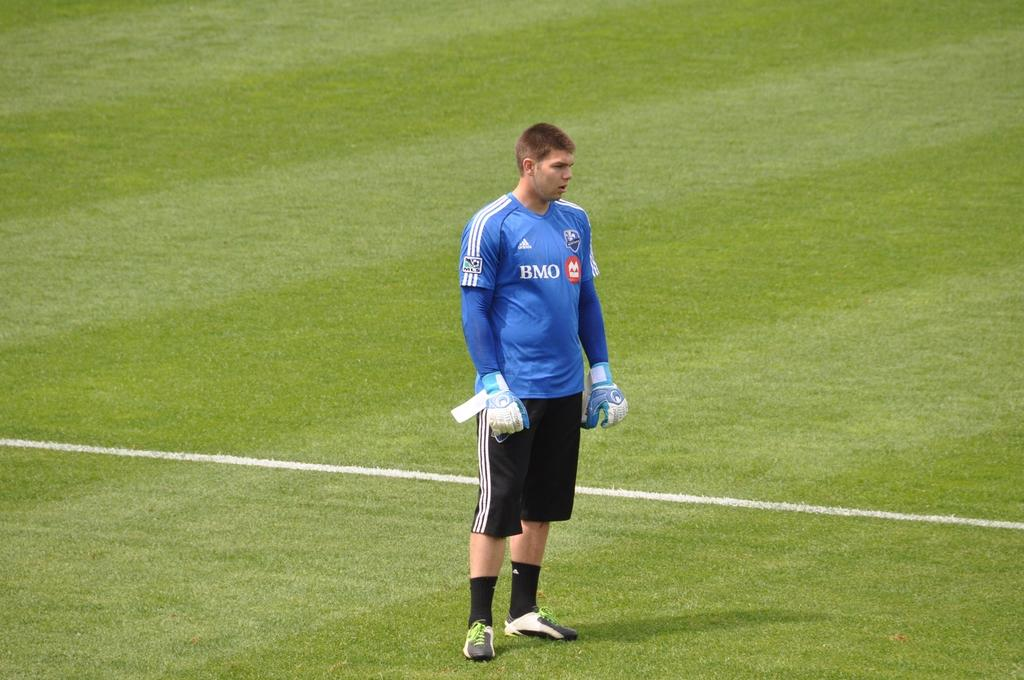<image>
Create a compact narrative representing the image presented. A soccer player wearing a BMO jersey stands on the fiedl 